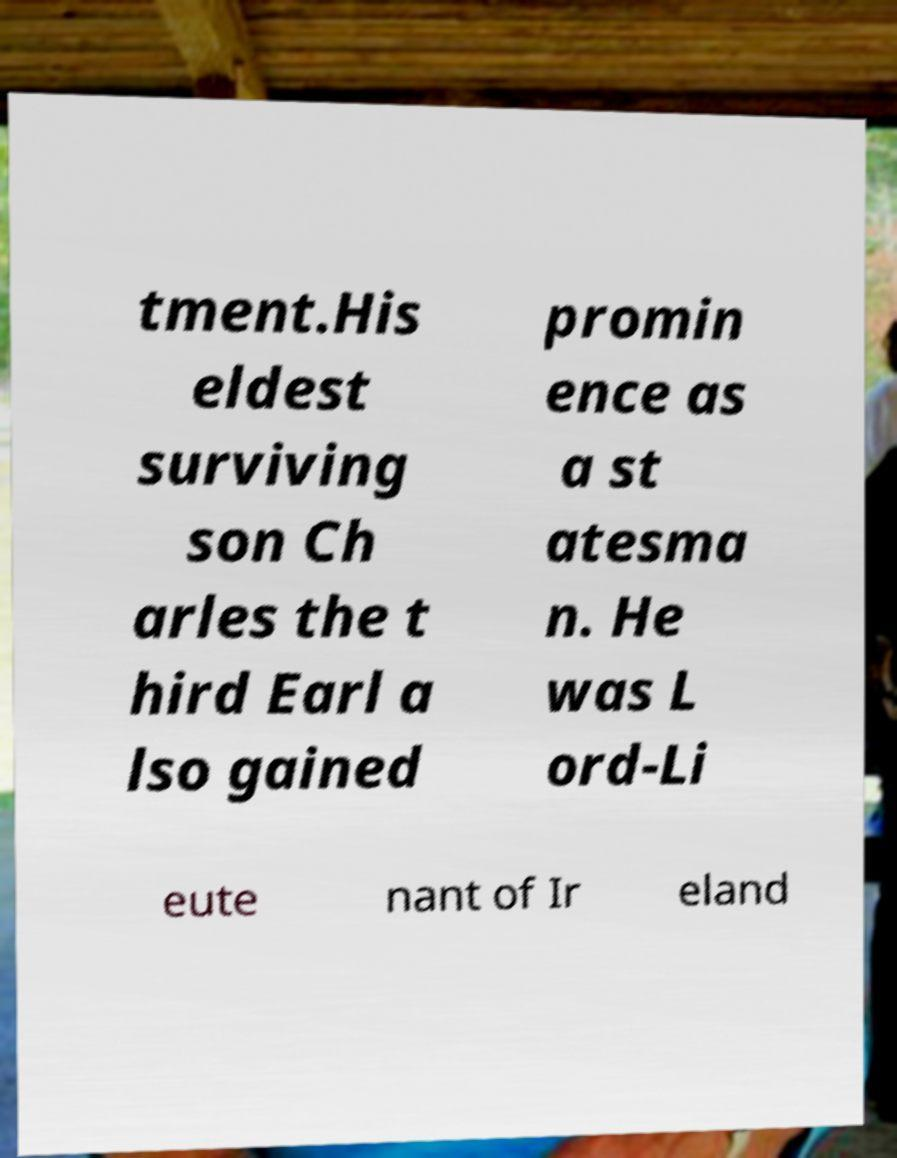Please read and relay the text visible in this image. What does it say? tment.His eldest surviving son Ch arles the t hird Earl a lso gained promin ence as a st atesma n. He was L ord-Li eute nant of Ir eland 